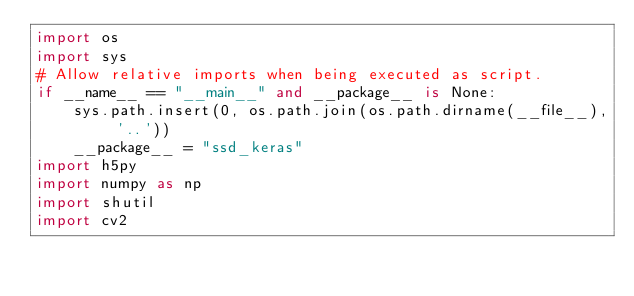Convert code to text. <code><loc_0><loc_0><loc_500><loc_500><_Python_>import os
import sys
# Allow relative imports when being executed as script.
if __name__ == "__main__" and __package__ is None:
    sys.path.insert(0, os.path.join(os.path.dirname(__file__), '..'))
    __package__ = "ssd_keras"
import h5py
import numpy as np
import shutil
import cv2
</code> 